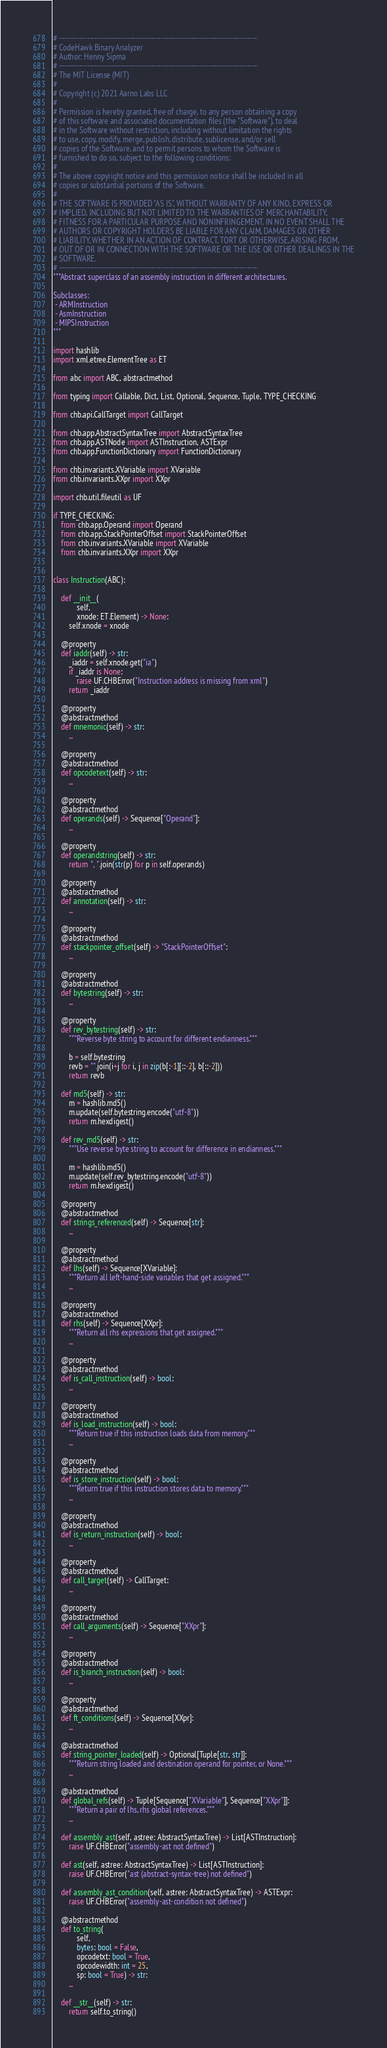Convert code to text. <code><loc_0><loc_0><loc_500><loc_500><_Python_># ------------------------------------------------------------------------------
# CodeHawk Binary Analyzer
# Author: Henny Sipma
# ------------------------------------------------------------------------------
# The MIT License (MIT)
#
# Copyright (c) 2021 Aarno Labs LLC
#
# Permission is hereby granted, free of charge, to any person obtaining a copy
# of this software and associated documentation files (the "Software"), to deal
# in the Software without restriction, including without limitation the rights
# to use, copy, modify, merge, publish, distribute, sublicense, and/or sell
# copies of the Software, and to permit persons to whom the Software is
# furnished to do so, subject to the following conditions:
#
# The above copyright notice and this permission notice shall be included in all
# copies or substantial portions of the Software.
#
# THE SOFTWARE IS PROVIDED "AS IS", WITHOUT WARRANTY OF ANY KIND, EXPRESS OR
# IMPLIED, INCLUDING BUT NOT LIMITED TO THE WARRANTIES OF MERCHANTABILITY,
# FITNESS FOR A PARTICULAR PURPOSE AND NONINFRINGEMENT. IN NO EVENT SHALL THE
# AUTHORS OR COPYRIGHT HOLDERS BE LIABLE FOR ANY CLAIM, DAMAGES OR OTHER
# LIABILITY, WHETHER IN AN ACTION OF CONTRACT, TORT OR OTHERWISE, ARISING FROM,
# OUT OF OR IN CONNECTION WITH THE SOFTWARE OR THE USE OR OTHER DEALINGS IN THE
# SOFTWARE.
# ------------------------------------------------------------------------------
"""Abstract superclass of an assembly instruction in different architectures.

Subclasses:
 - ARMInstruction
 - AsmInstruction
 - MIPSInstruction
"""

import hashlib
import xml.etree.ElementTree as ET

from abc import ABC, abstractmethod

from typing import Callable, Dict, List, Optional, Sequence, Tuple, TYPE_CHECKING

from chb.api.CallTarget import CallTarget

from chb.app.AbstractSyntaxTree import AbstractSyntaxTree
from chb.app.ASTNode import ASTInstruction, ASTExpr
from chb.app.FunctionDictionary import FunctionDictionary

from chb.invariants.XVariable import XVariable
from chb.invariants.XXpr import XXpr

import chb.util.fileutil as UF

if TYPE_CHECKING:
    from chb.app.Operand import Operand
    from chb.app.StackPointerOffset import StackPointerOffset
    from chb.invariants.XVariable import XVariable
    from chb.invariants.XXpr import XXpr


class Instruction(ABC):

    def __init__(
            self,
            xnode: ET.Element) -> None:
        self.xnode = xnode

    @property
    def iaddr(self) -> str:
        _iaddr = self.xnode.get("ia")
        if _iaddr is None:
            raise UF.CHBError("Instruction address is missing from xml")
        return _iaddr

    @property
    @abstractmethod
    def mnemonic(self) -> str:
        ...

    @property
    @abstractmethod
    def opcodetext(self) -> str:
        ...

    @property
    @abstractmethod
    def operands(self) -> Sequence["Operand"]:
        ...

    @property
    def operandstring(self) -> str:
        return ", ".join(str(p) for p in self.operands)

    @property
    @abstractmethod
    def annotation(self) -> str:
        ...

    @property
    @abstractmethod
    def stackpointer_offset(self) -> "StackPointerOffset":
        ...

    @property
    @abstractmethod
    def bytestring(self) -> str:
        ...

    @property
    def rev_bytestring(self) -> str:
        """Reverse byte string to account for different endianness."""

        b = self.bytestring
        revb = "".join(i+j for i, j in zip(b[:-1][::-2], b[::-2]))
        return revb

    def md5(self) -> str:
        m = hashlib.md5()
        m.update(self.bytestring.encode("utf-8"))
        return m.hexdigest()

    def rev_md5(self) -> str:
        """Use reverse byte string to account for difference in endianness."""

        m = hashlib.md5()
        m.update(self.rev_bytestring.encode("utf-8"))
        return m.hexdigest()

    @property
    @abstractmethod
    def strings_referenced(self) -> Sequence[str]:
        ...

    @property
    @abstractmethod
    def lhs(self) -> Sequence[XVariable]:
        """Return all left-hand-side variables that get assigned."""
        ...

    @property
    @abstractmethod
    def rhs(self) -> Sequence[XXpr]:
        """Return all rhs expressions that get assigned."""
        ...

    @property
    @abstractmethod
    def is_call_instruction(self) -> bool:
        ...

    @property
    @abstractmethod
    def is_load_instruction(self) -> bool:
        """Return true if this instruction loads data from memory."""
        ...

    @property
    @abstractmethod
    def is_store_instruction(self) -> bool:
        """Return true if this instruction stores data to memory."""
        ...

    @property
    @abstractmethod
    def is_return_instruction(self) -> bool:
        ...

    @property
    @abstractmethod
    def call_target(self) -> CallTarget:
        ...

    @property
    @abstractmethod
    def call_arguments(self) -> Sequence["XXpr"]:
        ...

    @property
    @abstractmethod
    def is_branch_instruction(self) -> bool:
        ...

    @property
    @abstractmethod
    def ft_conditions(self) -> Sequence[XXpr]:
        ...

    @abstractmethod
    def string_pointer_loaded(self) -> Optional[Tuple[str, str]]:
        """Return string loaded and destination operand for pointer, or None."""
        ...

    @abstractmethod
    def global_refs(self) -> Tuple[Sequence["XVariable"], Sequence["XXpr"]]:
        """Return a pair of lhs, rhs global references."""
        ...

    def assembly_ast(self, astree: AbstractSyntaxTree) -> List[ASTInstruction]:
        raise UF.CHBError("assembly-ast not defined")

    def ast(self, astree: AbstractSyntaxTree) -> List[ASTInstruction]:
        raise UF.CHBError("ast (abstract-syntax-tree) not defined")

    def assembly_ast_condition(self, astree: AbstractSyntaxTree) -> ASTExpr:
        raise UF.CHBError("assembly-ast-condition not defined")

    @abstractmethod
    def to_string(
            self,
            bytes: bool = False,
            opcodetxt: bool = True,
            opcodewidth: int = 25,
            sp: bool = True) -> str:
        ...

    def __str__(self) -> str:
        return self.to_string()
</code> 